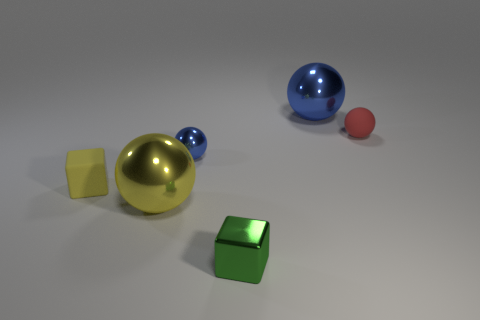If you had to guess, what purpose might this arrangement of objects serve? This arrangement of objects might be an artistic display meant to showcase contrasts in color, size, and texture. Alternatively, it could be a scene from a 3D modeling software used for teaching concepts of spatial awareness and object relations. 